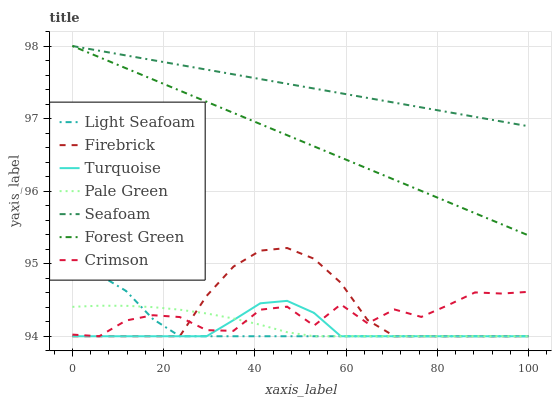Does Turquoise have the minimum area under the curve?
Answer yes or no. Yes. Does Seafoam have the maximum area under the curve?
Answer yes or no. Yes. Does Firebrick have the minimum area under the curve?
Answer yes or no. No. Does Firebrick have the maximum area under the curve?
Answer yes or no. No. Is Seafoam the smoothest?
Answer yes or no. Yes. Is Crimson the roughest?
Answer yes or no. Yes. Is Firebrick the smoothest?
Answer yes or no. No. Is Firebrick the roughest?
Answer yes or no. No. Does Seafoam have the lowest value?
Answer yes or no. No. Does Forest Green have the highest value?
Answer yes or no. Yes. Does Firebrick have the highest value?
Answer yes or no. No. Is Turquoise less than Seafoam?
Answer yes or no. Yes. Is Forest Green greater than Firebrick?
Answer yes or no. Yes. Does Light Seafoam intersect Pale Green?
Answer yes or no. Yes. Is Light Seafoam less than Pale Green?
Answer yes or no. No. Is Light Seafoam greater than Pale Green?
Answer yes or no. No. Does Turquoise intersect Seafoam?
Answer yes or no. No. 